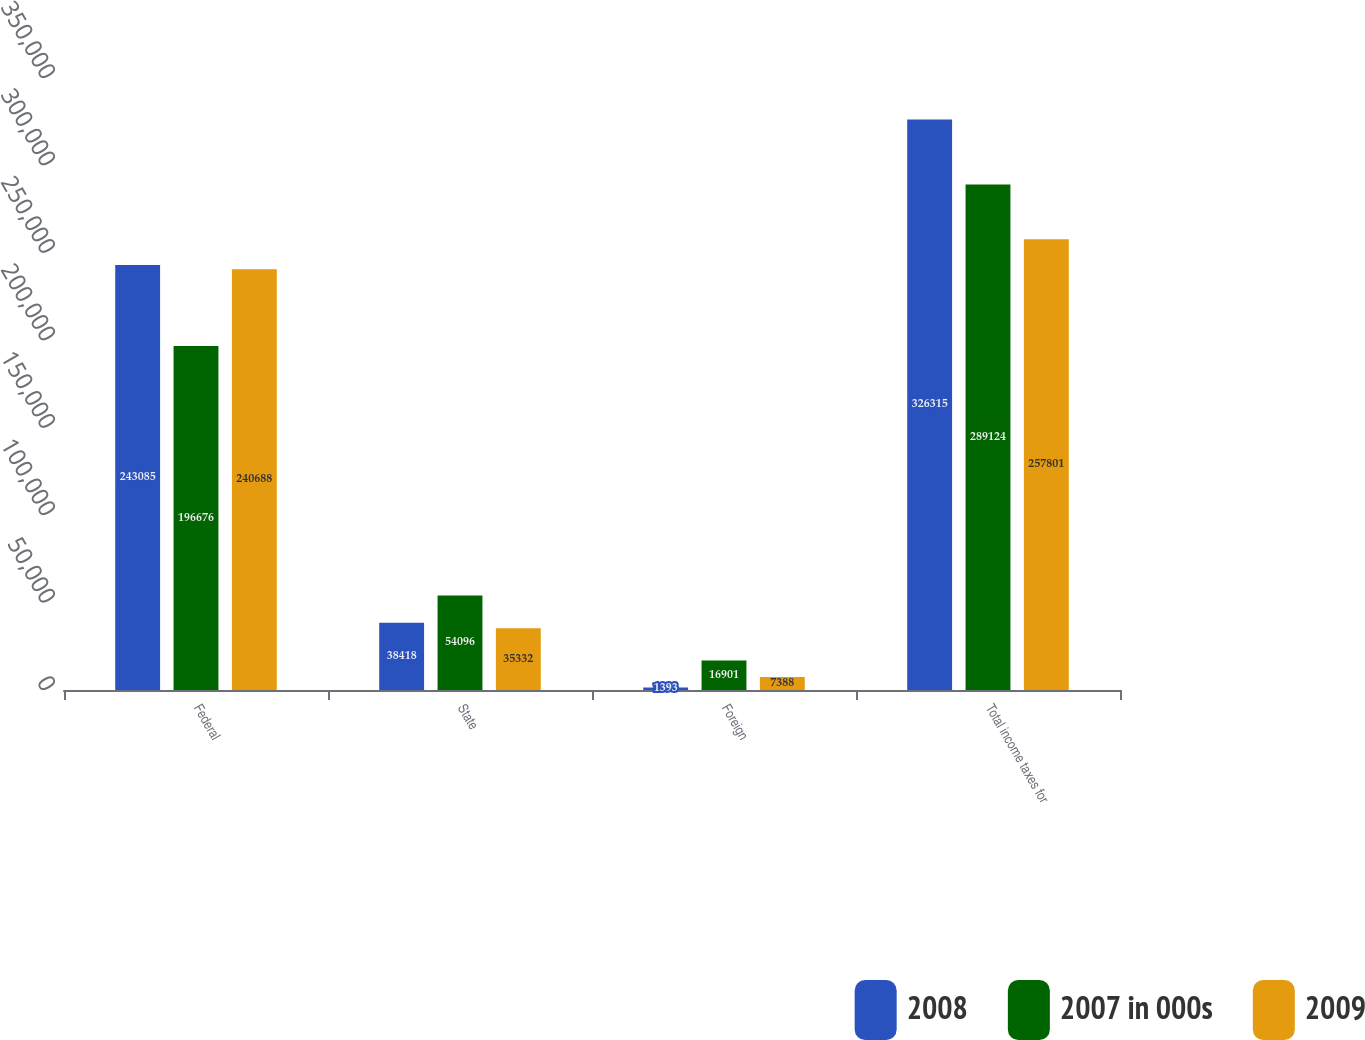Convert chart to OTSL. <chart><loc_0><loc_0><loc_500><loc_500><stacked_bar_chart><ecel><fcel>Federal<fcel>State<fcel>Foreign<fcel>Total income taxes for<nl><fcel>2008<fcel>243085<fcel>38418<fcel>1393<fcel>326315<nl><fcel>2007 in 000s<fcel>196676<fcel>54096<fcel>16901<fcel>289124<nl><fcel>2009<fcel>240688<fcel>35332<fcel>7388<fcel>257801<nl></chart> 